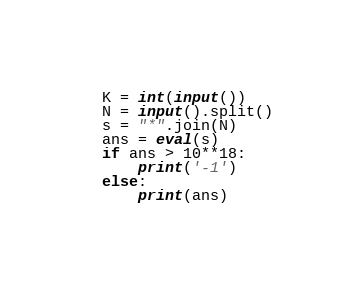<code> <loc_0><loc_0><loc_500><loc_500><_Python_>K = int(input())
N = input().split()
s = "*".join(N)
ans = eval(s)
if ans > 10**18:
    print('-1')
else:
    print(ans)</code> 